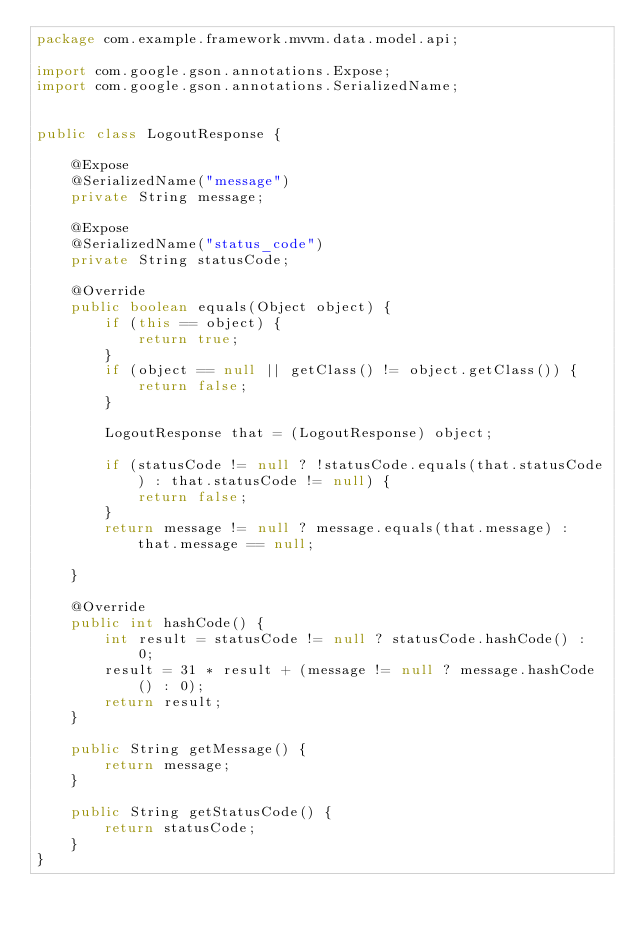<code> <loc_0><loc_0><loc_500><loc_500><_Java_>package com.example.framework.mvvm.data.model.api;

import com.google.gson.annotations.Expose;
import com.google.gson.annotations.SerializedName;


public class LogoutResponse {

    @Expose
    @SerializedName("message")
    private String message;

    @Expose
    @SerializedName("status_code")
    private String statusCode;

    @Override
    public boolean equals(Object object) {
        if (this == object) {
            return true;
        }
        if (object == null || getClass() != object.getClass()) {
            return false;
        }

        LogoutResponse that = (LogoutResponse) object;

        if (statusCode != null ? !statusCode.equals(that.statusCode) : that.statusCode != null) {
            return false;
        }
        return message != null ? message.equals(that.message) : that.message == null;

    }

    @Override
    public int hashCode() {
        int result = statusCode != null ? statusCode.hashCode() : 0;
        result = 31 * result + (message != null ? message.hashCode() : 0);
        return result;
    }

    public String getMessage() {
        return message;
    }

    public String getStatusCode() {
        return statusCode;
    }
}
</code> 